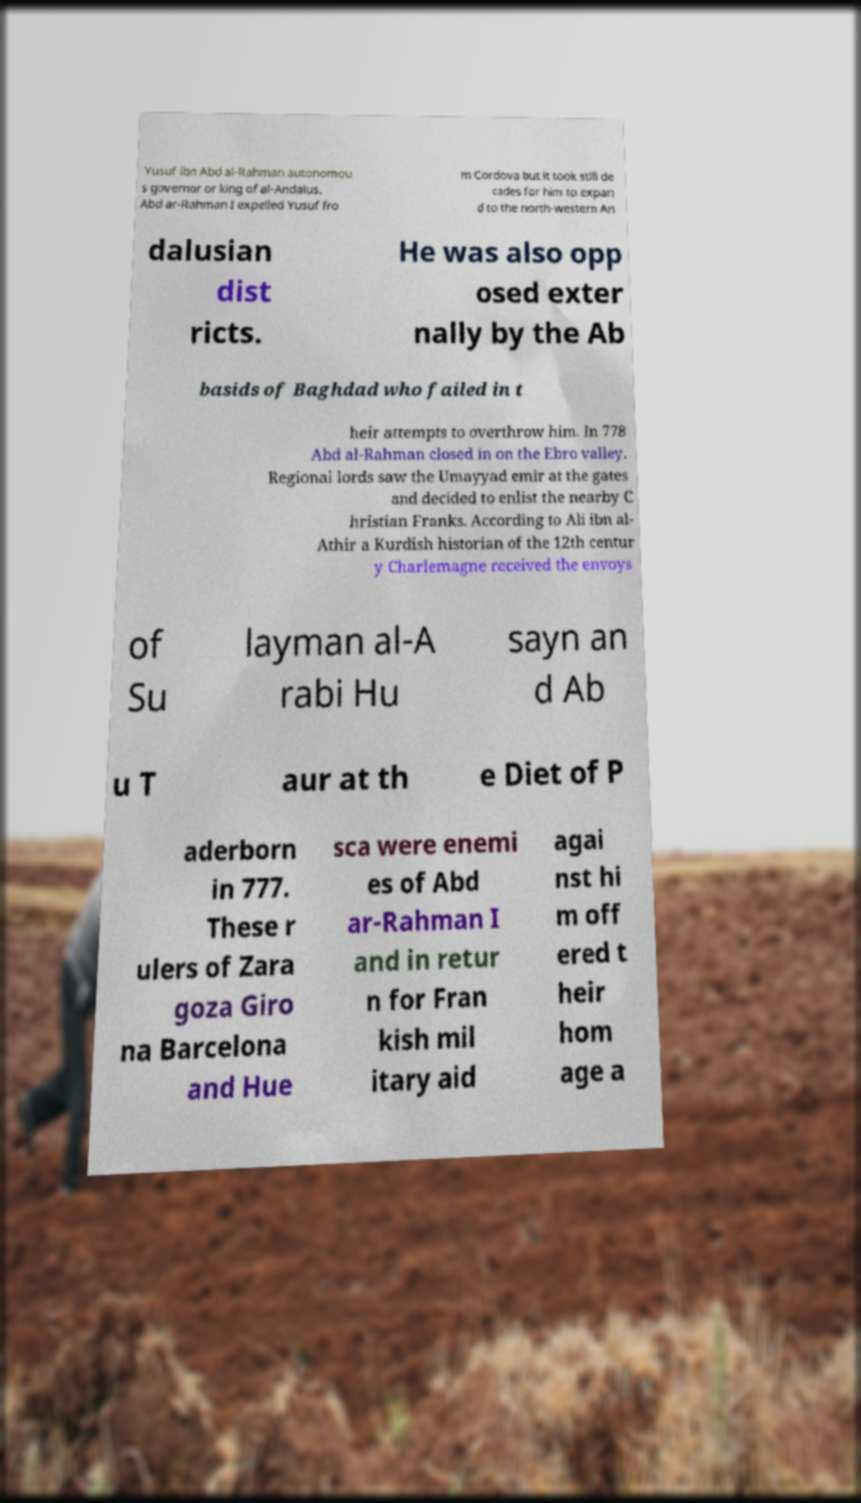Can you accurately transcribe the text from the provided image for me? Yusuf ibn Abd al-Rahman autonomou s governor or king of al-Andalus. Abd ar-Rahman I expelled Yusuf fro m Cordova but it took still de cades for him to expan d to the north-western An dalusian dist ricts. He was also opp osed exter nally by the Ab basids of Baghdad who failed in t heir attempts to overthrow him. In 778 Abd al-Rahman closed in on the Ebro valley. Regional lords saw the Umayyad emir at the gates and decided to enlist the nearby C hristian Franks. According to Ali ibn al- Athir a Kurdish historian of the 12th centur y Charlemagne received the envoys of Su layman al-A rabi Hu sayn an d Ab u T aur at th e Diet of P aderborn in 777. These r ulers of Zara goza Giro na Barcelona and Hue sca were enemi es of Abd ar-Rahman I and in retur n for Fran kish mil itary aid agai nst hi m off ered t heir hom age a 